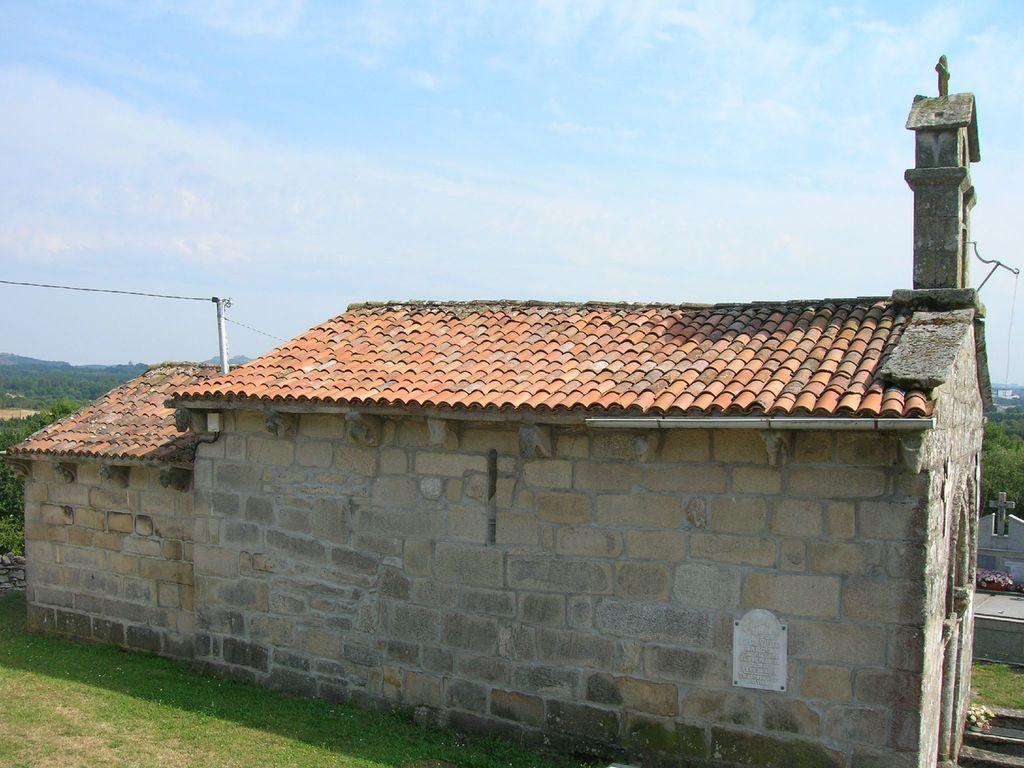What type of structure is in the image? There is a house in the image. What type of vegetation is visible at the bottom of the image? Grass is visible at the bottom of the image. What can be seen in the background of the image? Greenery is present in the background of the image. What is visible at the top of the image? The sky is visible at the top of the image. What can be observed in the sky? Clouds are present in the sky. How much salt is sprinkled on the grass in the image? There is no salt present in the image; only grass is visible at the bottom. 